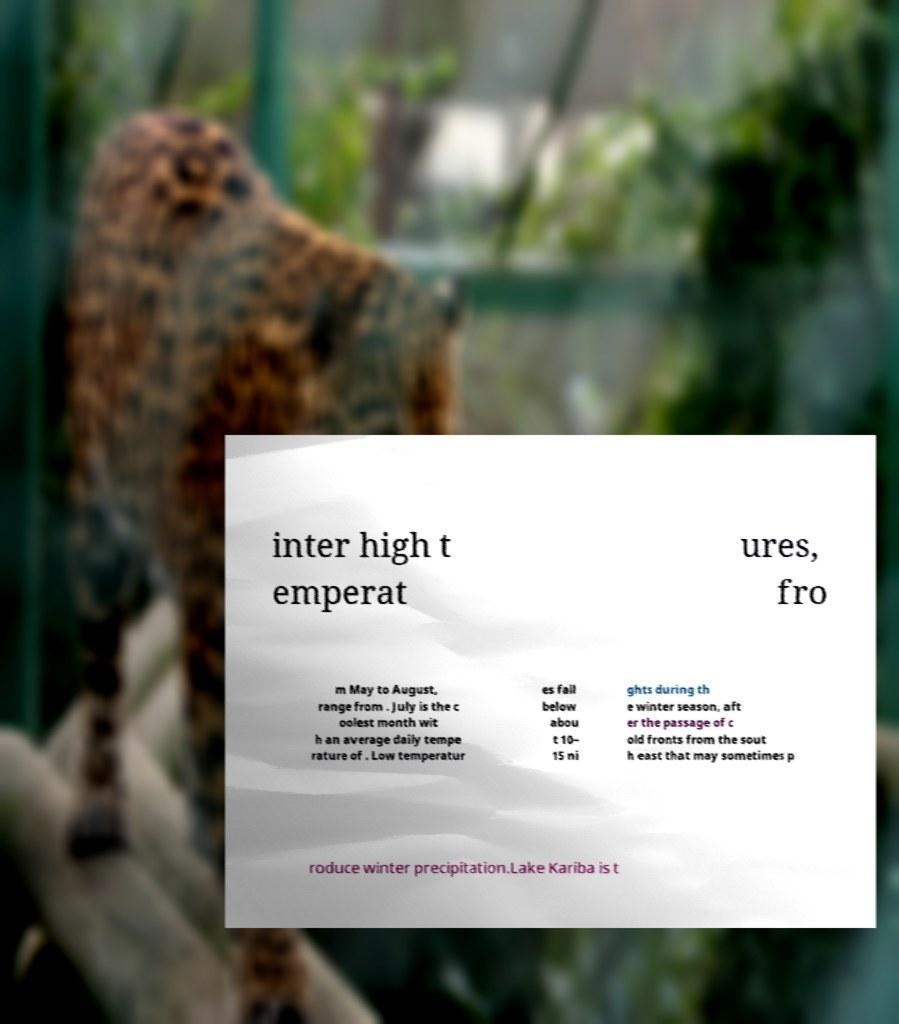Please read and relay the text visible in this image. What does it say? inter high t emperat ures, fro m May to August, range from . July is the c oolest month wit h an average daily tempe rature of . Low temperatur es fall below abou t 10– 15 ni ghts during th e winter season, aft er the passage of c old fronts from the sout h east that may sometimes p roduce winter precipitation.Lake Kariba is t 